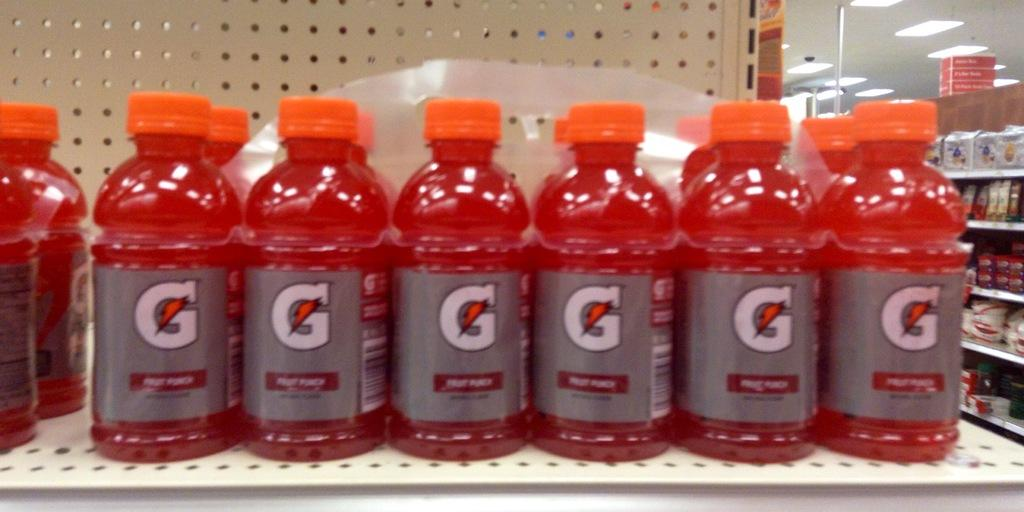What type of beverage containers are visible in the image? There are juice bottles in the image. Where are the juice bottles located? The juice bottles are in a shelf. Can you see a cat playing with a ray in the sea in the image? There is no cat, ray, or sea present in the image; it only features juice bottles in a shelf. 